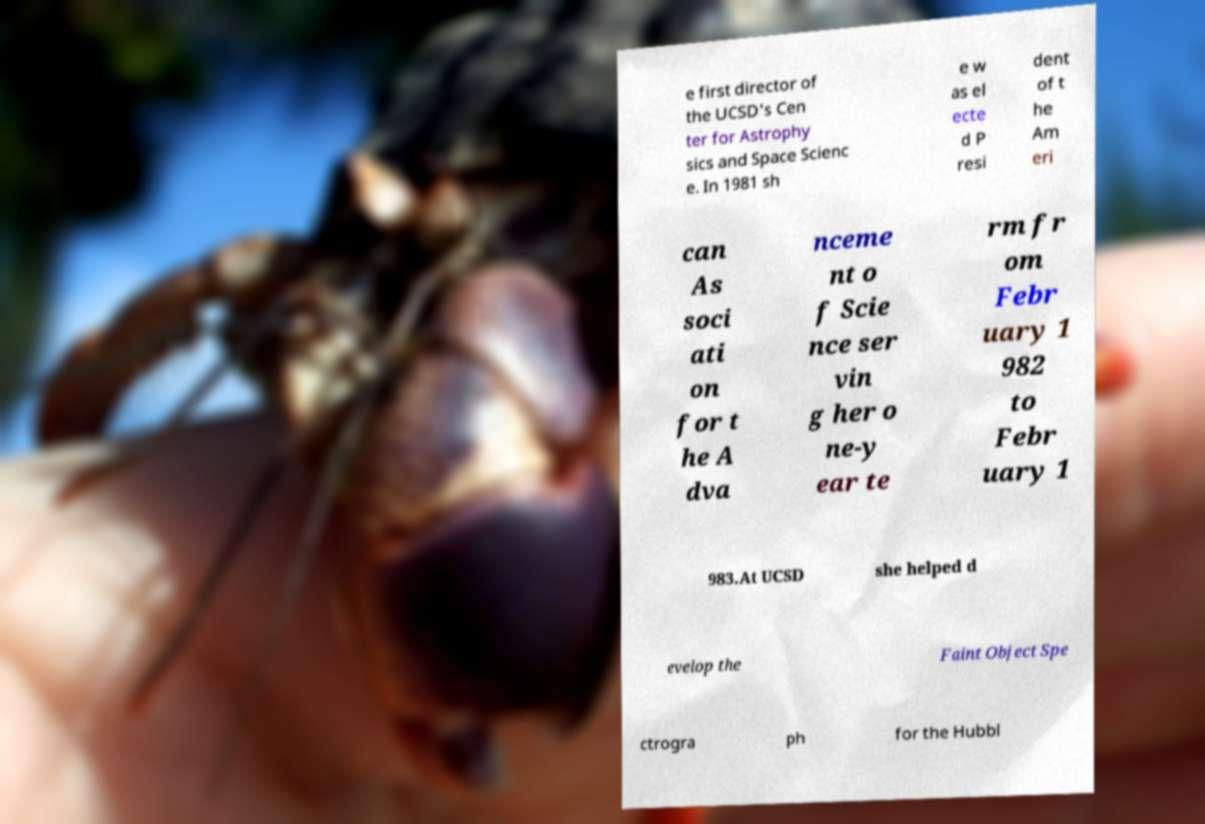For documentation purposes, I need the text within this image transcribed. Could you provide that? e first director of the UCSD's Cen ter for Astrophy sics and Space Scienc e. In 1981 sh e w as el ecte d P resi dent of t he Am eri can As soci ati on for t he A dva nceme nt o f Scie nce ser vin g her o ne-y ear te rm fr om Febr uary 1 982 to Febr uary 1 983.At UCSD she helped d evelop the Faint Object Spe ctrogra ph for the Hubbl 